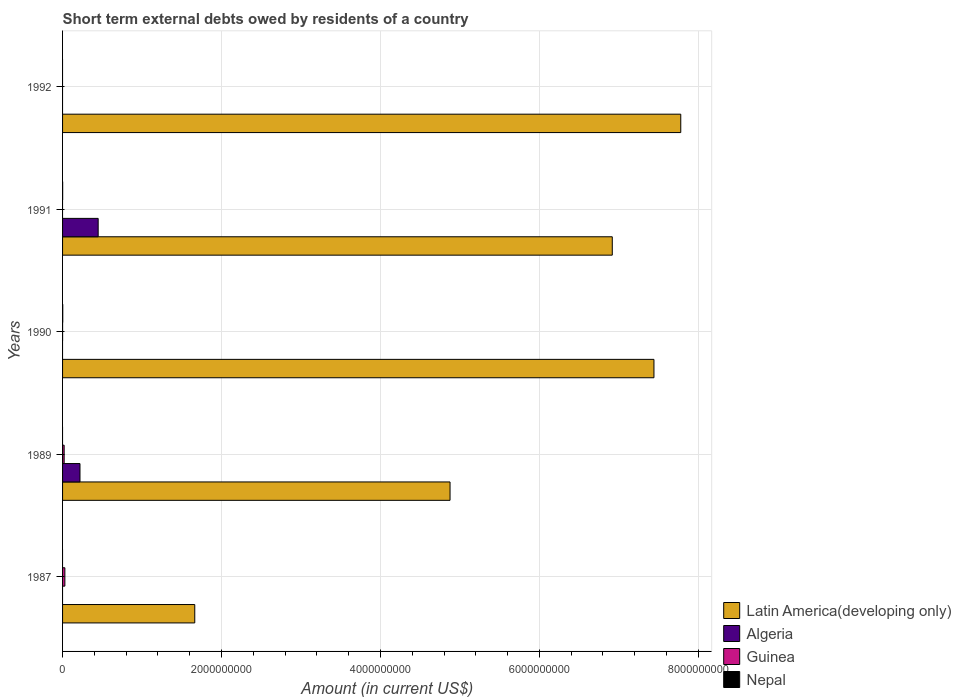How many different coloured bars are there?
Give a very brief answer. 4. Are the number of bars per tick equal to the number of legend labels?
Your response must be concise. No. Are the number of bars on each tick of the Y-axis equal?
Your response must be concise. No. How many bars are there on the 3rd tick from the top?
Ensure brevity in your answer.  3. How many bars are there on the 2nd tick from the bottom?
Offer a terse response. 3. In how many cases, is the number of bars for a given year not equal to the number of legend labels?
Make the answer very short. 5. What is the amount of short-term external debts owed by residents in Nepal in 1992?
Your answer should be very brief. 0. Across all years, what is the maximum amount of short-term external debts owed by residents in Algeria?
Make the answer very short. 4.48e+08. Across all years, what is the minimum amount of short-term external debts owed by residents in Latin America(developing only)?
Ensure brevity in your answer.  1.66e+09. What is the total amount of short-term external debts owed by residents in Nepal in the graph?
Your answer should be compact. 3.50e+06. What is the difference between the amount of short-term external debts owed by residents in Latin America(developing only) in 1989 and that in 1990?
Offer a very short reply. -2.57e+09. What is the difference between the amount of short-term external debts owed by residents in Nepal in 1990 and the amount of short-term external debts owed by residents in Guinea in 1991?
Keep it short and to the point. 2.40e+06. What is the average amount of short-term external debts owed by residents in Algeria per year?
Offer a terse response. 1.33e+08. In the year 1989, what is the difference between the amount of short-term external debts owed by residents in Algeria and amount of short-term external debts owed by residents in Latin America(developing only)?
Offer a very short reply. -4.66e+09. What is the ratio of the amount of short-term external debts owed by residents in Latin America(developing only) in 1989 to that in 1990?
Offer a very short reply. 0.66. What is the difference between the highest and the second highest amount of short-term external debts owed by residents in Guinea?
Give a very brief answer. 9.00e+06. What is the difference between the highest and the lowest amount of short-term external debts owed by residents in Algeria?
Offer a very short reply. 4.48e+08. In how many years, is the amount of short-term external debts owed by residents in Guinea greater than the average amount of short-term external debts owed by residents in Guinea taken over all years?
Make the answer very short. 2. Is the sum of the amount of short-term external debts owed by residents in Latin America(developing only) in 1990 and 1992 greater than the maximum amount of short-term external debts owed by residents in Nepal across all years?
Ensure brevity in your answer.  Yes. Is it the case that in every year, the sum of the amount of short-term external debts owed by residents in Latin America(developing only) and amount of short-term external debts owed by residents in Nepal is greater than the sum of amount of short-term external debts owed by residents in Guinea and amount of short-term external debts owed by residents in Algeria?
Your answer should be compact. No. Are all the bars in the graph horizontal?
Your answer should be compact. Yes. How many years are there in the graph?
Offer a terse response. 5. What is the difference between two consecutive major ticks on the X-axis?
Make the answer very short. 2.00e+09. Where does the legend appear in the graph?
Make the answer very short. Bottom right. How many legend labels are there?
Ensure brevity in your answer.  4. What is the title of the graph?
Keep it short and to the point. Short term external debts owed by residents of a country. What is the label or title of the Y-axis?
Your response must be concise. Years. What is the Amount (in current US$) in Latin America(developing only) in 1987?
Keep it short and to the point. 1.66e+09. What is the Amount (in current US$) of Guinea in 1987?
Offer a terse response. 2.90e+07. What is the Amount (in current US$) of Latin America(developing only) in 1989?
Ensure brevity in your answer.  4.88e+09. What is the Amount (in current US$) in Algeria in 1989?
Your response must be concise. 2.19e+08. What is the Amount (in current US$) in Latin America(developing only) in 1990?
Ensure brevity in your answer.  7.44e+09. What is the Amount (in current US$) in Algeria in 1990?
Ensure brevity in your answer.  0. What is the Amount (in current US$) in Nepal in 1990?
Provide a short and direct response. 2.40e+06. What is the Amount (in current US$) in Latin America(developing only) in 1991?
Your answer should be very brief. 6.92e+09. What is the Amount (in current US$) in Algeria in 1991?
Ensure brevity in your answer.  4.48e+08. What is the Amount (in current US$) in Guinea in 1991?
Make the answer very short. 0. What is the Amount (in current US$) in Nepal in 1991?
Ensure brevity in your answer.  1.10e+06. What is the Amount (in current US$) in Latin America(developing only) in 1992?
Provide a succinct answer. 7.78e+09. What is the Amount (in current US$) of Nepal in 1992?
Offer a terse response. 0. Across all years, what is the maximum Amount (in current US$) of Latin America(developing only)?
Your answer should be compact. 7.78e+09. Across all years, what is the maximum Amount (in current US$) of Algeria?
Provide a short and direct response. 4.48e+08. Across all years, what is the maximum Amount (in current US$) in Guinea?
Keep it short and to the point. 2.90e+07. Across all years, what is the maximum Amount (in current US$) of Nepal?
Offer a terse response. 2.40e+06. Across all years, what is the minimum Amount (in current US$) of Latin America(developing only)?
Provide a short and direct response. 1.66e+09. Across all years, what is the minimum Amount (in current US$) in Algeria?
Provide a short and direct response. 0. Across all years, what is the minimum Amount (in current US$) of Guinea?
Provide a succinct answer. 0. Across all years, what is the minimum Amount (in current US$) in Nepal?
Ensure brevity in your answer.  0. What is the total Amount (in current US$) in Latin America(developing only) in the graph?
Provide a succinct answer. 2.87e+1. What is the total Amount (in current US$) in Algeria in the graph?
Your response must be concise. 6.67e+08. What is the total Amount (in current US$) in Guinea in the graph?
Provide a short and direct response. 4.92e+07. What is the total Amount (in current US$) in Nepal in the graph?
Ensure brevity in your answer.  3.50e+06. What is the difference between the Amount (in current US$) in Latin America(developing only) in 1987 and that in 1989?
Your answer should be compact. -3.21e+09. What is the difference between the Amount (in current US$) in Guinea in 1987 and that in 1989?
Provide a succinct answer. 9.00e+06. What is the difference between the Amount (in current US$) of Latin America(developing only) in 1987 and that in 1990?
Ensure brevity in your answer.  -5.78e+09. What is the difference between the Amount (in current US$) of Guinea in 1987 and that in 1990?
Offer a terse response. 2.88e+07. What is the difference between the Amount (in current US$) in Latin America(developing only) in 1987 and that in 1991?
Offer a terse response. -5.25e+09. What is the difference between the Amount (in current US$) in Latin America(developing only) in 1987 and that in 1992?
Your response must be concise. -6.12e+09. What is the difference between the Amount (in current US$) in Latin America(developing only) in 1989 and that in 1990?
Make the answer very short. -2.57e+09. What is the difference between the Amount (in current US$) in Guinea in 1989 and that in 1990?
Keep it short and to the point. 1.98e+07. What is the difference between the Amount (in current US$) of Latin America(developing only) in 1989 and that in 1991?
Your response must be concise. -2.04e+09. What is the difference between the Amount (in current US$) of Algeria in 1989 and that in 1991?
Give a very brief answer. -2.29e+08. What is the difference between the Amount (in current US$) in Latin America(developing only) in 1989 and that in 1992?
Provide a short and direct response. -2.90e+09. What is the difference between the Amount (in current US$) in Latin America(developing only) in 1990 and that in 1991?
Offer a terse response. 5.24e+08. What is the difference between the Amount (in current US$) of Nepal in 1990 and that in 1991?
Your response must be concise. 1.30e+06. What is the difference between the Amount (in current US$) in Latin America(developing only) in 1990 and that in 1992?
Provide a short and direct response. -3.37e+08. What is the difference between the Amount (in current US$) of Latin America(developing only) in 1991 and that in 1992?
Offer a terse response. -8.62e+08. What is the difference between the Amount (in current US$) of Latin America(developing only) in 1987 and the Amount (in current US$) of Algeria in 1989?
Your answer should be very brief. 1.44e+09. What is the difference between the Amount (in current US$) in Latin America(developing only) in 1987 and the Amount (in current US$) in Guinea in 1989?
Provide a short and direct response. 1.64e+09. What is the difference between the Amount (in current US$) in Latin America(developing only) in 1987 and the Amount (in current US$) in Guinea in 1990?
Provide a short and direct response. 1.66e+09. What is the difference between the Amount (in current US$) of Latin America(developing only) in 1987 and the Amount (in current US$) of Nepal in 1990?
Provide a short and direct response. 1.66e+09. What is the difference between the Amount (in current US$) in Guinea in 1987 and the Amount (in current US$) in Nepal in 1990?
Keep it short and to the point. 2.66e+07. What is the difference between the Amount (in current US$) of Latin America(developing only) in 1987 and the Amount (in current US$) of Algeria in 1991?
Your answer should be very brief. 1.22e+09. What is the difference between the Amount (in current US$) in Latin America(developing only) in 1987 and the Amount (in current US$) in Nepal in 1991?
Offer a very short reply. 1.66e+09. What is the difference between the Amount (in current US$) of Guinea in 1987 and the Amount (in current US$) of Nepal in 1991?
Your answer should be compact. 2.79e+07. What is the difference between the Amount (in current US$) in Latin America(developing only) in 1989 and the Amount (in current US$) in Guinea in 1990?
Give a very brief answer. 4.88e+09. What is the difference between the Amount (in current US$) of Latin America(developing only) in 1989 and the Amount (in current US$) of Nepal in 1990?
Ensure brevity in your answer.  4.87e+09. What is the difference between the Amount (in current US$) in Algeria in 1989 and the Amount (in current US$) in Guinea in 1990?
Your response must be concise. 2.19e+08. What is the difference between the Amount (in current US$) of Algeria in 1989 and the Amount (in current US$) of Nepal in 1990?
Make the answer very short. 2.17e+08. What is the difference between the Amount (in current US$) of Guinea in 1989 and the Amount (in current US$) of Nepal in 1990?
Your answer should be very brief. 1.76e+07. What is the difference between the Amount (in current US$) in Latin America(developing only) in 1989 and the Amount (in current US$) in Algeria in 1991?
Make the answer very short. 4.43e+09. What is the difference between the Amount (in current US$) in Latin America(developing only) in 1989 and the Amount (in current US$) in Nepal in 1991?
Provide a short and direct response. 4.87e+09. What is the difference between the Amount (in current US$) of Algeria in 1989 and the Amount (in current US$) of Nepal in 1991?
Your answer should be very brief. 2.18e+08. What is the difference between the Amount (in current US$) of Guinea in 1989 and the Amount (in current US$) of Nepal in 1991?
Your answer should be compact. 1.89e+07. What is the difference between the Amount (in current US$) of Latin America(developing only) in 1990 and the Amount (in current US$) of Algeria in 1991?
Keep it short and to the point. 6.99e+09. What is the difference between the Amount (in current US$) of Latin America(developing only) in 1990 and the Amount (in current US$) of Nepal in 1991?
Offer a very short reply. 7.44e+09. What is the difference between the Amount (in current US$) of Guinea in 1990 and the Amount (in current US$) of Nepal in 1991?
Provide a succinct answer. -9.00e+05. What is the average Amount (in current US$) of Latin America(developing only) per year?
Provide a succinct answer. 5.74e+09. What is the average Amount (in current US$) in Algeria per year?
Provide a succinct answer. 1.33e+08. What is the average Amount (in current US$) in Guinea per year?
Make the answer very short. 9.84e+06. In the year 1987, what is the difference between the Amount (in current US$) of Latin America(developing only) and Amount (in current US$) of Guinea?
Provide a short and direct response. 1.63e+09. In the year 1989, what is the difference between the Amount (in current US$) of Latin America(developing only) and Amount (in current US$) of Algeria?
Offer a very short reply. 4.66e+09. In the year 1989, what is the difference between the Amount (in current US$) in Latin America(developing only) and Amount (in current US$) in Guinea?
Give a very brief answer. 4.86e+09. In the year 1989, what is the difference between the Amount (in current US$) in Algeria and Amount (in current US$) in Guinea?
Your response must be concise. 1.99e+08. In the year 1990, what is the difference between the Amount (in current US$) in Latin America(developing only) and Amount (in current US$) in Guinea?
Your answer should be very brief. 7.44e+09. In the year 1990, what is the difference between the Amount (in current US$) of Latin America(developing only) and Amount (in current US$) of Nepal?
Keep it short and to the point. 7.44e+09. In the year 1990, what is the difference between the Amount (in current US$) in Guinea and Amount (in current US$) in Nepal?
Ensure brevity in your answer.  -2.20e+06. In the year 1991, what is the difference between the Amount (in current US$) of Latin America(developing only) and Amount (in current US$) of Algeria?
Keep it short and to the point. 6.47e+09. In the year 1991, what is the difference between the Amount (in current US$) of Latin America(developing only) and Amount (in current US$) of Nepal?
Your answer should be very brief. 6.92e+09. In the year 1991, what is the difference between the Amount (in current US$) of Algeria and Amount (in current US$) of Nepal?
Provide a short and direct response. 4.47e+08. What is the ratio of the Amount (in current US$) of Latin America(developing only) in 1987 to that in 1989?
Your answer should be very brief. 0.34. What is the ratio of the Amount (in current US$) of Guinea in 1987 to that in 1989?
Your answer should be compact. 1.45. What is the ratio of the Amount (in current US$) in Latin America(developing only) in 1987 to that in 1990?
Your answer should be compact. 0.22. What is the ratio of the Amount (in current US$) of Guinea in 1987 to that in 1990?
Keep it short and to the point. 145. What is the ratio of the Amount (in current US$) in Latin America(developing only) in 1987 to that in 1991?
Your answer should be compact. 0.24. What is the ratio of the Amount (in current US$) in Latin America(developing only) in 1987 to that in 1992?
Your answer should be compact. 0.21. What is the ratio of the Amount (in current US$) of Latin America(developing only) in 1989 to that in 1990?
Offer a terse response. 0.66. What is the ratio of the Amount (in current US$) in Guinea in 1989 to that in 1990?
Offer a very short reply. 100. What is the ratio of the Amount (in current US$) in Latin America(developing only) in 1989 to that in 1991?
Your response must be concise. 0.7. What is the ratio of the Amount (in current US$) in Algeria in 1989 to that in 1991?
Ensure brevity in your answer.  0.49. What is the ratio of the Amount (in current US$) in Latin America(developing only) in 1989 to that in 1992?
Offer a very short reply. 0.63. What is the ratio of the Amount (in current US$) of Latin America(developing only) in 1990 to that in 1991?
Offer a very short reply. 1.08. What is the ratio of the Amount (in current US$) of Nepal in 1990 to that in 1991?
Keep it short and to the point. 2.18. What is the ratio of the Amount (in current US$) of Latin America(developing only) in 1990 to that in 1992?
Offer a very short reply. 0.96. What is the ratio of the Amount (in current US$) of Latin America(developing only) in 1991 to that in 1992?
Keep it short and to the point. 0.89. What is the difference between the highest and the second highest Amount (in current US$) of Latin America(developing only)?
Keep it short and to the point. 3.37e+08. What is the difference between the highest and the second highest Amount (in current US$) in Guinea?
Ensure brevity in your answer.  9.00e+06. What is the difference between the highest and the lowest Amount (in current US$) in Latin America(developing only)?
Your response must be concise. 6.12e+09. What is the difference between the highest and the lowest Amount (in current US$) in Algeria?
Make the answer very short. 4.48e+08. What is the difference between the highest and the lowest Amount (in current US$) of Guinea?
Offer a very short reply. 2.90e+07. What is the difference between the highest and the lowest Amount (in current US$) of Nepal?
Offer a terse response. 2.40e+06. 